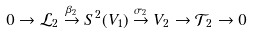<formula> <loc_0><loc_0><loc_500><loc_500>0 \rightarrow \mathcal { L } _ { 2 } \stackrel { \beta _ { 2 } } { \rightarrow } S ^ { 2 } ( V _ { 1 } ) \stackrel { \sigma _ { 2 } } { \rightarrow } V _ { 2 } \rightarrow \mathcal { T } _ { 2 } \rightarrow 0</formula> 